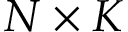Convert formula to latex. <formula><loc_0><loc_0><loc_500><loc_500>N \times K</formula> 